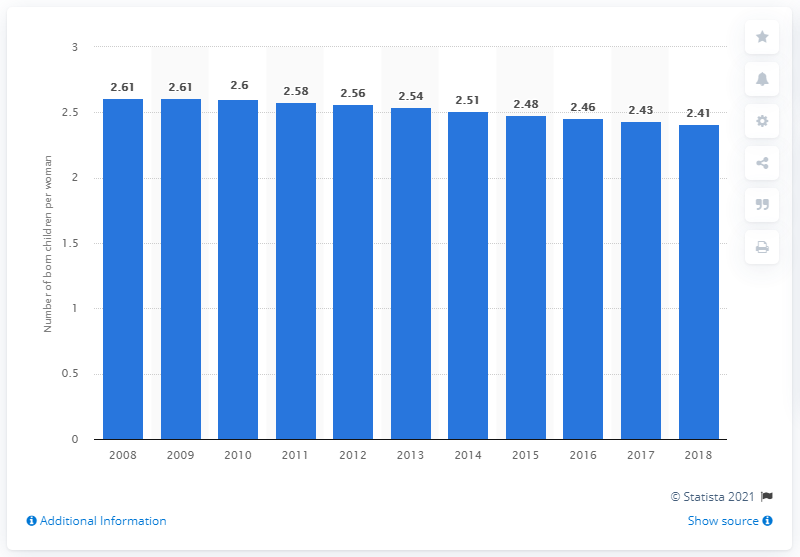Highlight a few significant elements in this photo. The fertility rate in South Africa in 2018 was 2.41. 